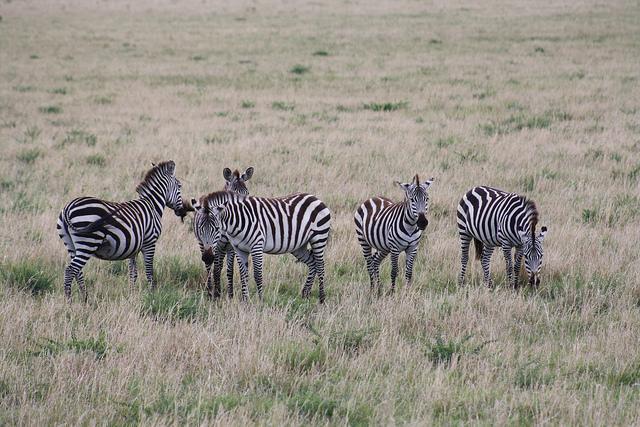How many zebras are there?
Give a very brief answer. 5. How many zebra?
Give a very brief answer. 5. 